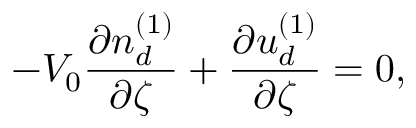<formula> <loc_0><loc_0><loc_500><loc_500>- V _ { 0 } \frac { \partial n _ { d } ^ { ( 1 ) } } { \partial \zeta } + \frac { \partial u _ { d } ^ { ( 1 ) } } { \partial \zeta } = 0 ,</formula> 